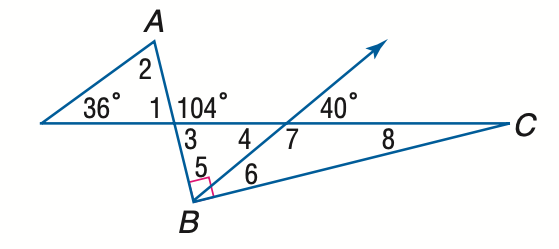Answer the mathemtical geometry problem and directly provide the correct option letter.
Question: Find the measure of \angle 4 if A B \perp B C.
Choices: A: 36 B: 38 C: 40 D: 42 C 